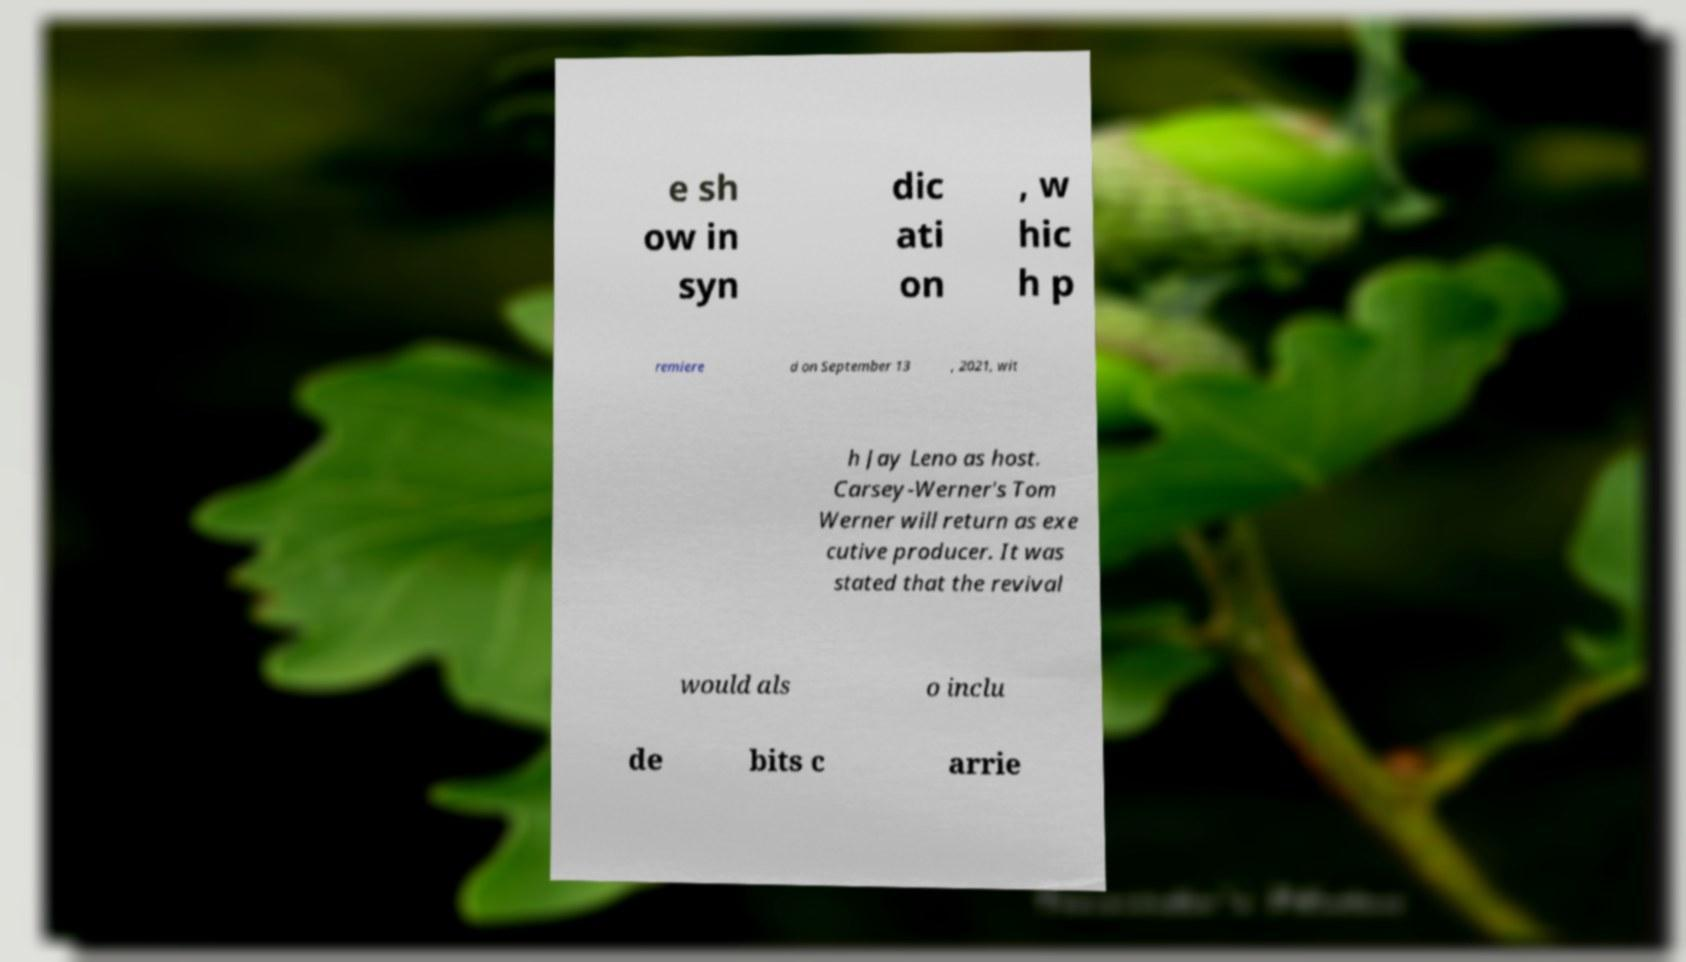Can you read and provide the text displayed in the image?This photo seems to have some interesting text. Can you extract and type it out for me? e sh ow in syn dic ati on , w hic h p remiere d on September 13 , 2021, wit h Jay Leno as host. Carsey-Werner's Tom Werner will return as exe cutive producer. It was stated that the revival would als o inclu de bits c arrie 